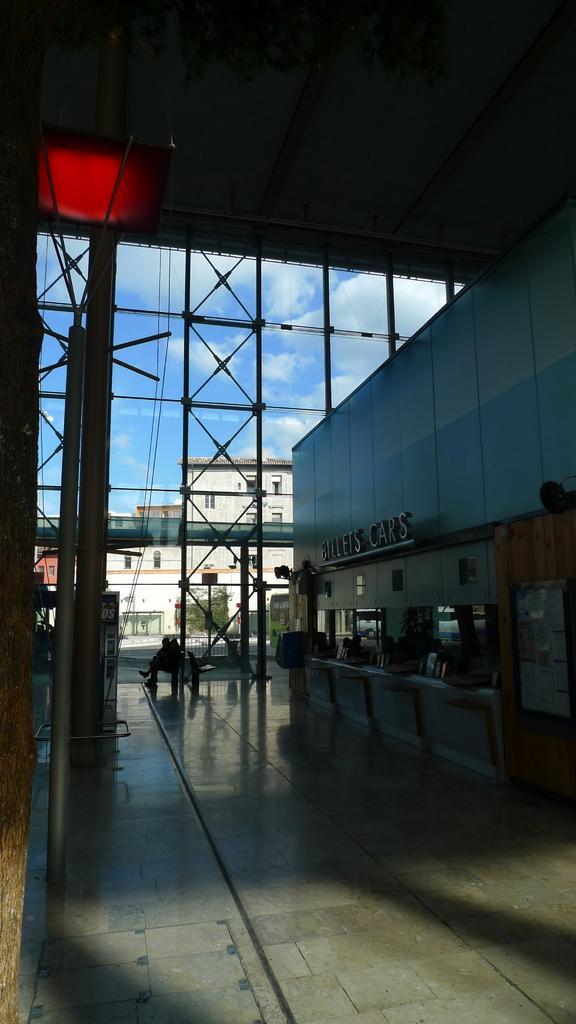Could you give a brief overview of what you see in this image? In this picture I can see the inside view of a building, and in the background there are buildings and the sky. 